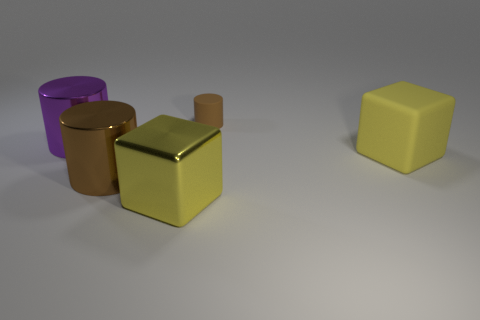Are there fewer large yellow rubber cubes behind the small brown rubber object than purple objects?
Offer a terse response. Yes. There is a purple thing that is the same size as the metal cube; what is its material?
Ensure brevity in your answer.  Metal. There is a thing that is both to the right of the yellow metal block and left of the matte cube; how big is it?
Your response must be concise. Small. There is a brown matte object that is the same shape as the purple thing; what size is it?
Offer a terse response. Small. How many objects are either purple shiny things or cylinders behind the large brown shiny object?
Provide a short and direct response. 2. What shape is the tiny brown thing?
Offer a very short reply. Cylinder. What shape is the big shiny object that is behind the yellow thing to the right of the large shiny cube?
Your response must be concise. Cylinder. What material is the object that is the same color as the shiny cube?
Provide a succinct answer. Rubber. The large thing that is the same material as the tiny brown thing is what color?
Provide a succinct answer. Yellow. Is there anything else that has the same size as the brown rubber thing?
Ensure brevity in your answer.  No. 